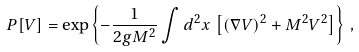Convert formula to latex. <formula><loc_0><loc_0><loc_500><loc_500>P [ V ] = \exp \left \{ - \frac { 1 } { 2 g M ^ { 2 } } \int d ^ { 2 } x \, \left [ ( \nabla V ) ^ { 2 } + M ^ { 2 } V ^ { 2 } \right ] \right \} \, ,</formula> 